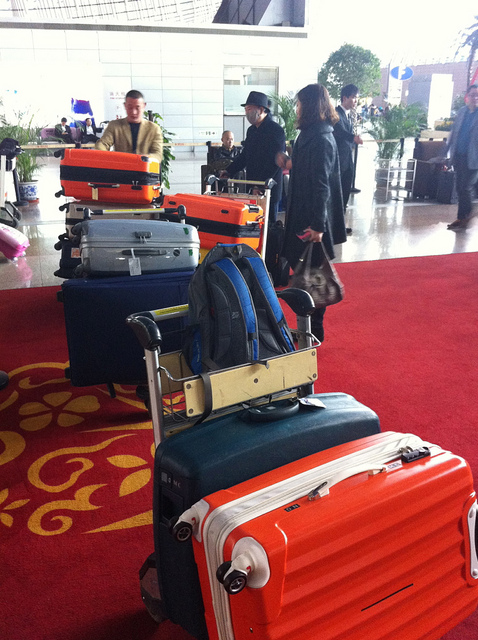Does the image give any indication of the time of year? The image does not offer any obvious seasonal cues such as holiday decorations or seasonal clothing. Therefore, we cannot accurately infer the time of year from this picture. 